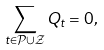<formula> <loc_0><loc_0><loc_500><loc_500>\sum _ { t \in \mathcal { P } \cup \mathcal { Z } } Q _ { t } = 0 ,</formula> 